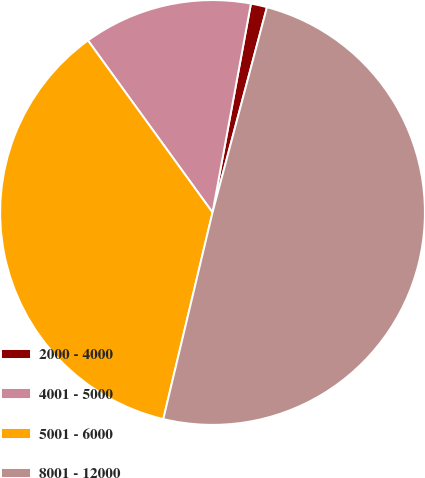<chart> <loc_0><loc_0><loc_500><loc_500><pie_chart><fcel>2000 - 4000<fcel>4001 - 5000<fcel>5001 - 6000<fcel>8001 - 12000<nl><fcel>1.23%<fcel>12.87%<fcel>36.3%<fcel>49.6%<nl></chart> 